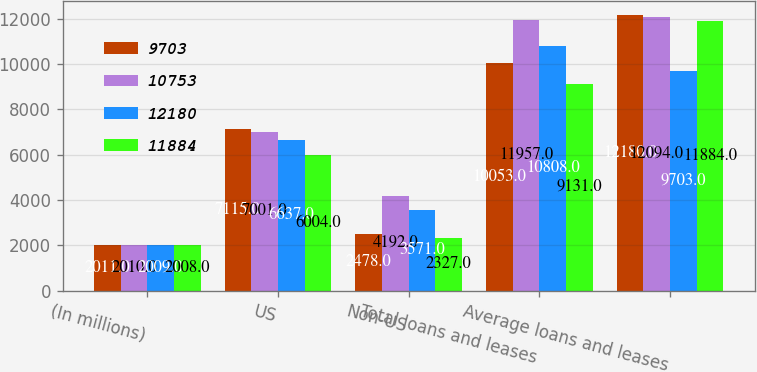<chart> <loc_0><loc_0><loc_500><loc_500><stacked_bar_chart><ecel><fcel>(In millions)<fcel>US<fcel>Non-US<fcel>Total loans and leases<fcel>Average loans and leases<nl><fcel>9703<fcel>2011<fcel>7115<fcel>2478<fcel>10053<fcel>12180<nl><fcel>10753<fcel>2010<fcel>7001<fcel>4192<fcel>11957<fcel>12094<nl><fcel>12180<fcel>2009<fcel>6637<fcel>3571<fcel>10808<fcel>9703<nl><fcel>11884<fcel>2008<fcel>6004<fcel>2327<fcel>9131<fcel>11884<nl></chart> 